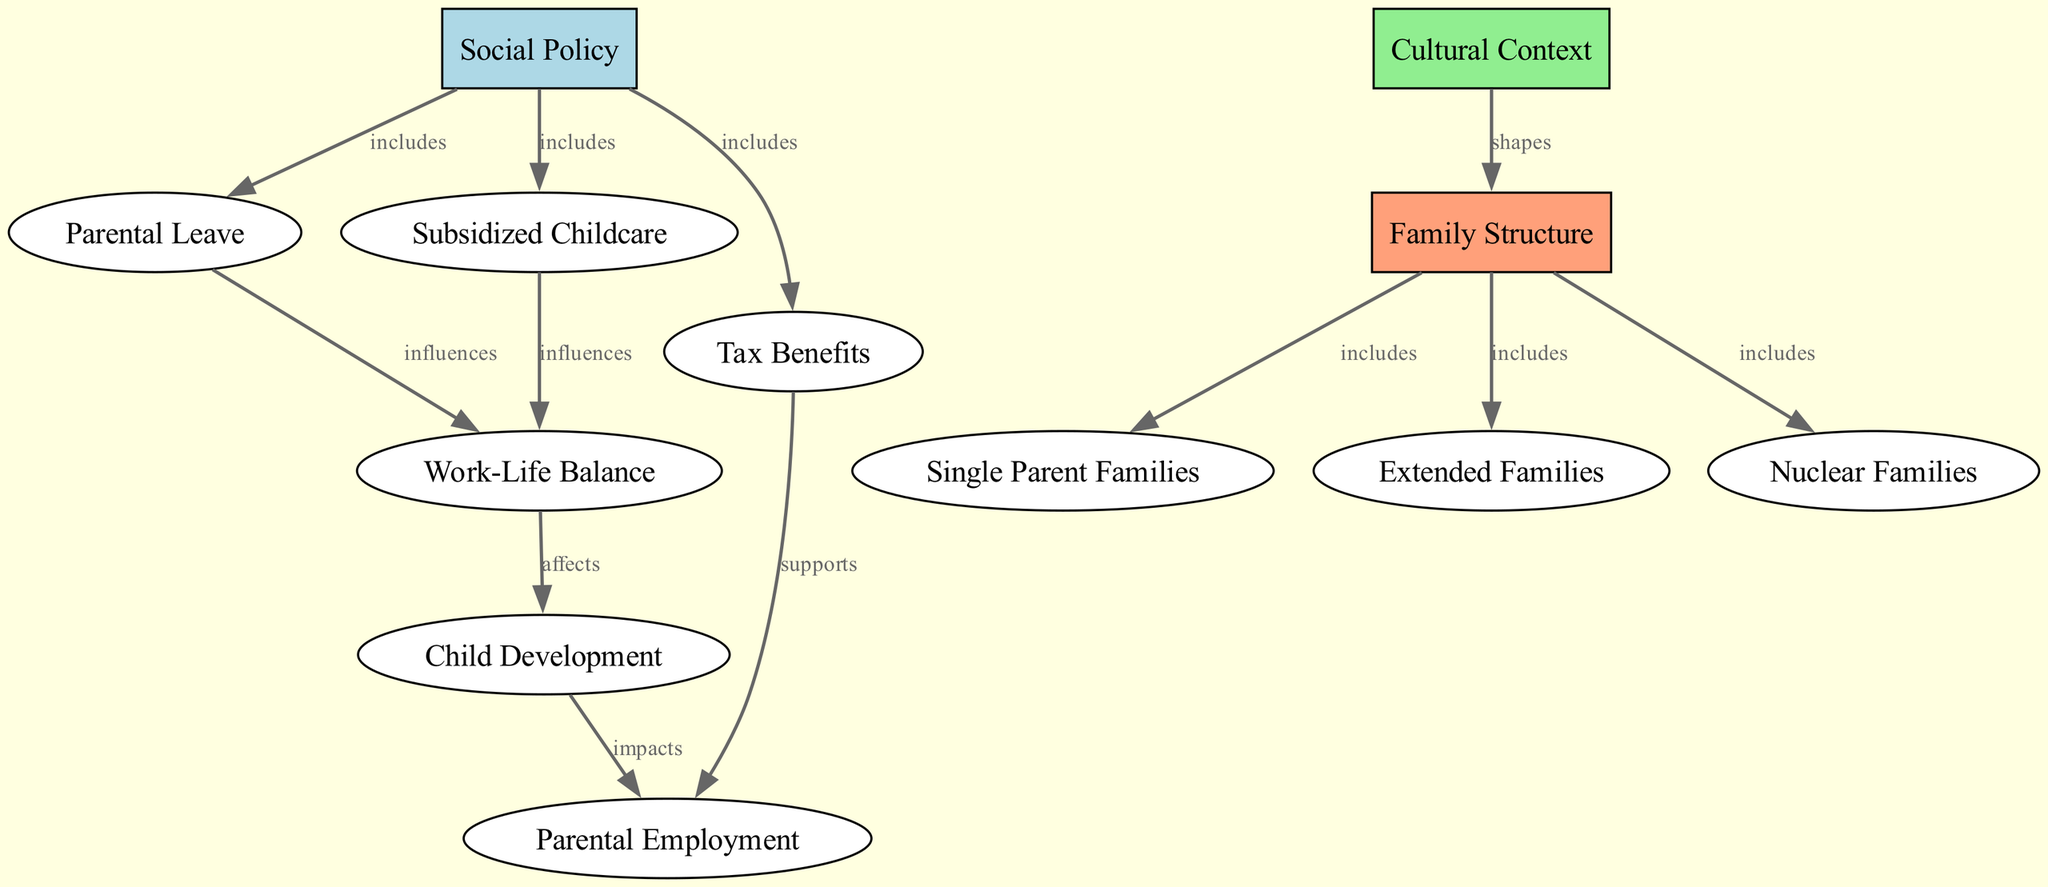What are the three types of family structures highlighted in the diagram? The diagram illustrates three types of family structures, which are categorized under the "Family Structure" node. Upon examining this node, it branches out to three specific structures: "Single Parent Families," "Extended Families," and "Nuclear Families."
Answer: Single Parent Families, Extended Families, Nuclear Families Which social policy includes parental leave? The "Social Policy" node includes several social policies. By tracing the edges from the "Social Policy" node, we find an edge connecting to the "Parental Leave" node, thus indicating that parental leave is a part of social policy.
Answer: Parental Leave What does parental leave influence? Parental leave influences "Work-Life Balance" as depicted in the diagram. Following the edges from "Parental Leave," we see a direct connection that specifies this influence.
Answer: Work-Life Balance How many total nodes are present in the diagram? Counting all the distinct nodes presented within the diagram gives a total of twelve nodes, which encompass various social policies, cultural contexts, family structures, and related concepts.
Answer: 12 Which node impacts parental employment? The "Child Development" node impacts "Parental Employment." To arrive at this conclusion, we trace the relationship in the diagram from "Child Development" to "Parental Employment," establishing the connection of influence.
Answer: Child Development What supports parental employment according to the diagram? The diagram shows that "Tax Benefits" supports "Parental Employment." This is deduced by following the edge from "Tax Benefits" directly to "Parental Employment," indicating their supportive relationship.
Answer: Tax Benefits Which factor shapes family structure? "Cultural Context" is the factor that shapes "Family Structure" in the diagram. By observing the connection from "Cultural Context" to "Family Structure," we can conclude this relationship.
Answer: Cultural Context How does work-life balance affect child development? The relationship outlined in the diagram shows that "Work-Life Balance" affects "Child Development." This is verified by tracking the flow from "Work-Life Balance" leading to "Child Development," showcasing this influence.
Answer: Child Development 